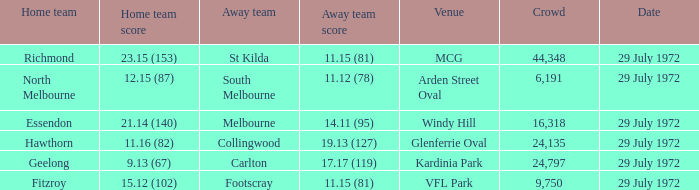When was the footscray away team's 11.15 (81) score recorded? 29 July 1972. 